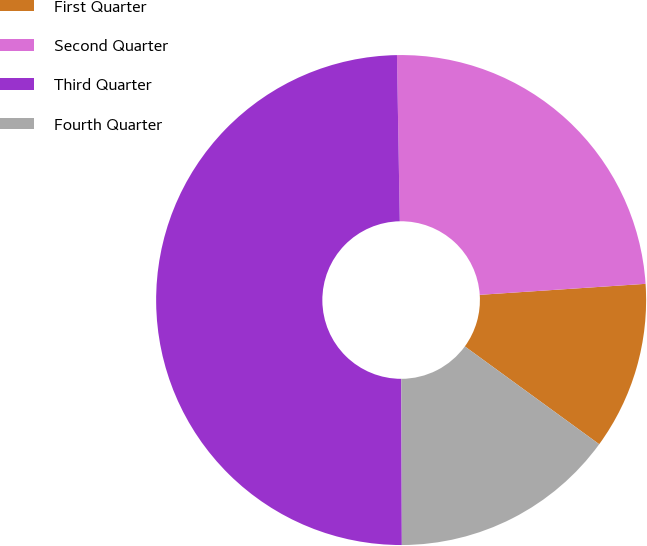Convert chart to OTSL. <chart><loc_0><loc_0><loc_500><loc_500><pie_chart><fcel>First Quarter<fcel>Second Quarter<fcel>Third Quarter<fcel>Fourth Quarter<nl><fcel>11.07%<fcel>24.22%<fcel>49.78%<fcel>14.94%<nl></chart> 